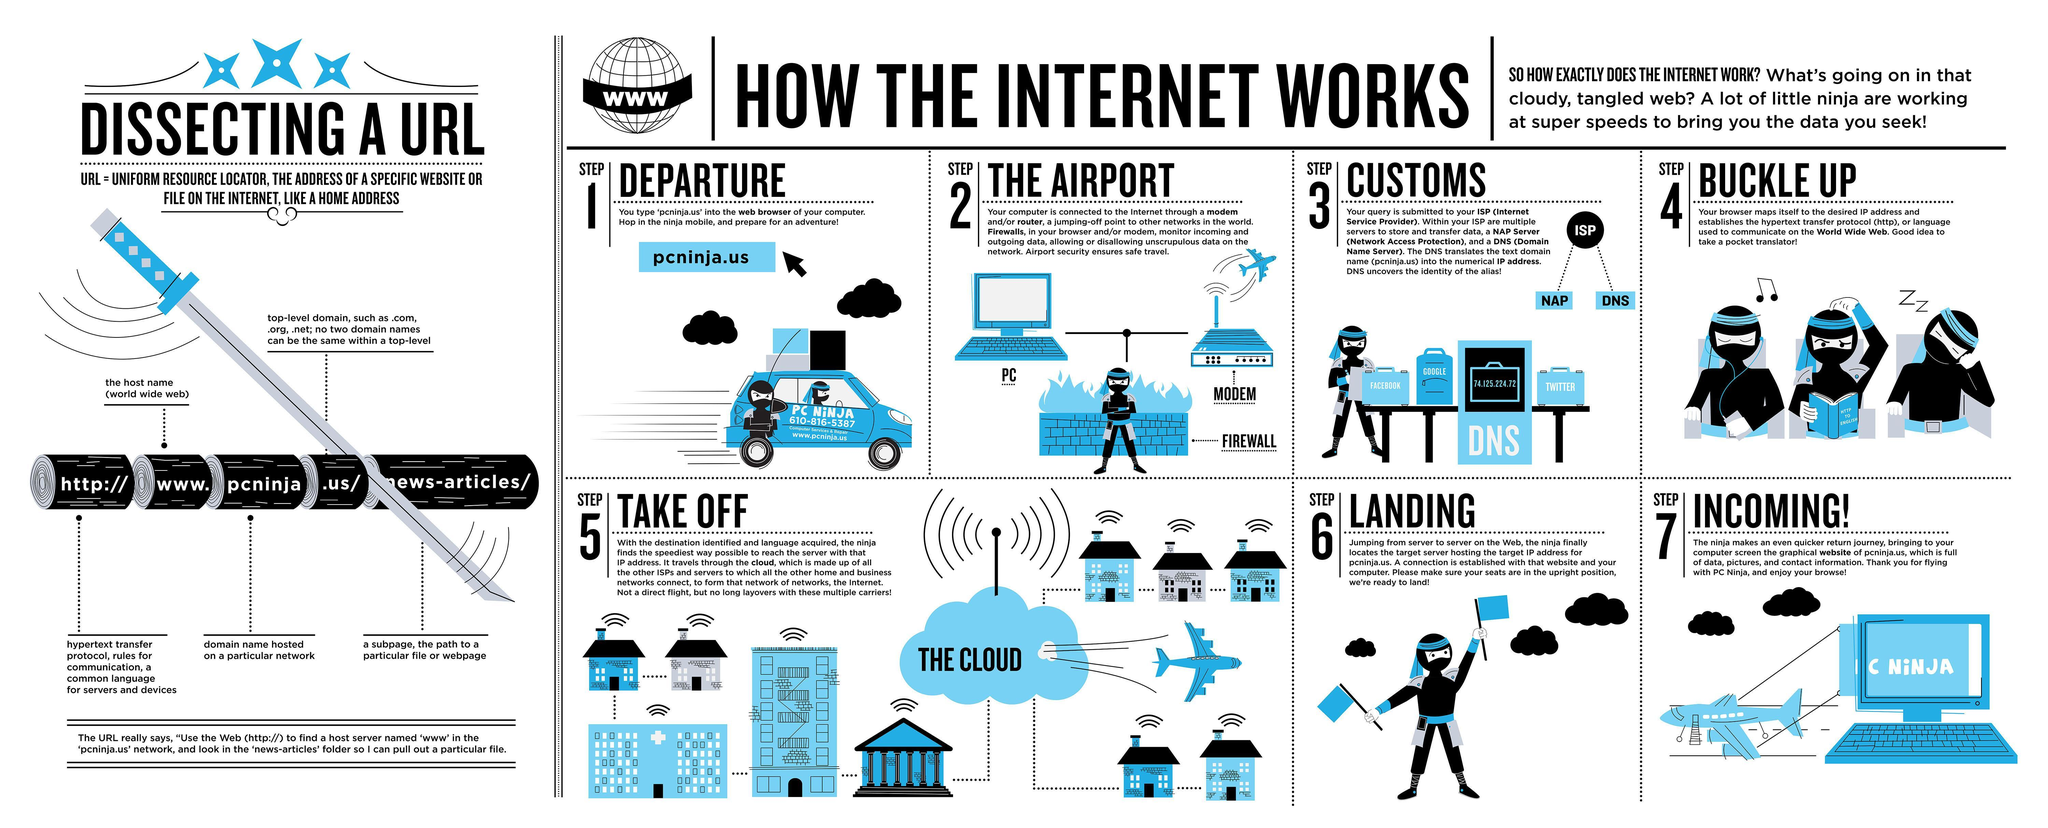what are the social media platforms shown in step 3 images
Answer the question with a short phrase. facebook, google, twitter In dissecting a url, what does www. indicate the host name (world wide web) What is the number written on the car 610-816-5387 